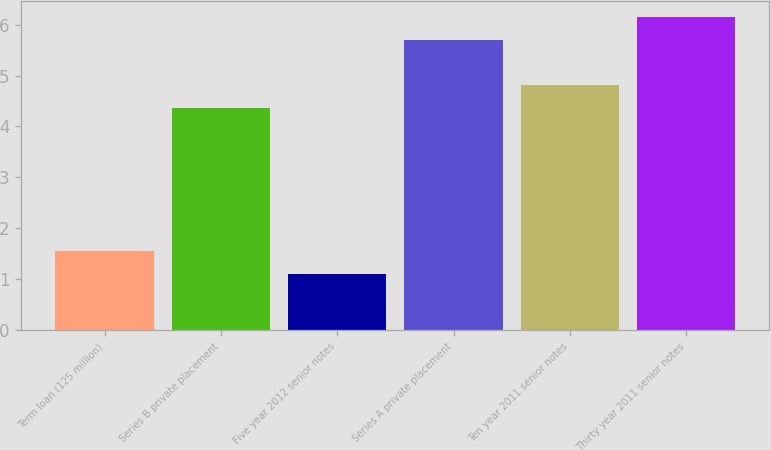Convert chart to OTSL. <chart><loc_0><loc_0><loc_500><loc_500><bar_chart><fcel>Term loan (125 million)<fcel>Series B private placement<fcel>Five year 2012 senior notes<fcel>Series A private placement<fcel>Ten year 2011 senior notes<fcel>Thirty year 2011 senior notes<nl><fcel>1.55<fcel>4.36<fcel>1.1<fcel>5.71<fcel>4.81<fcel>6.16<nl></chart> 